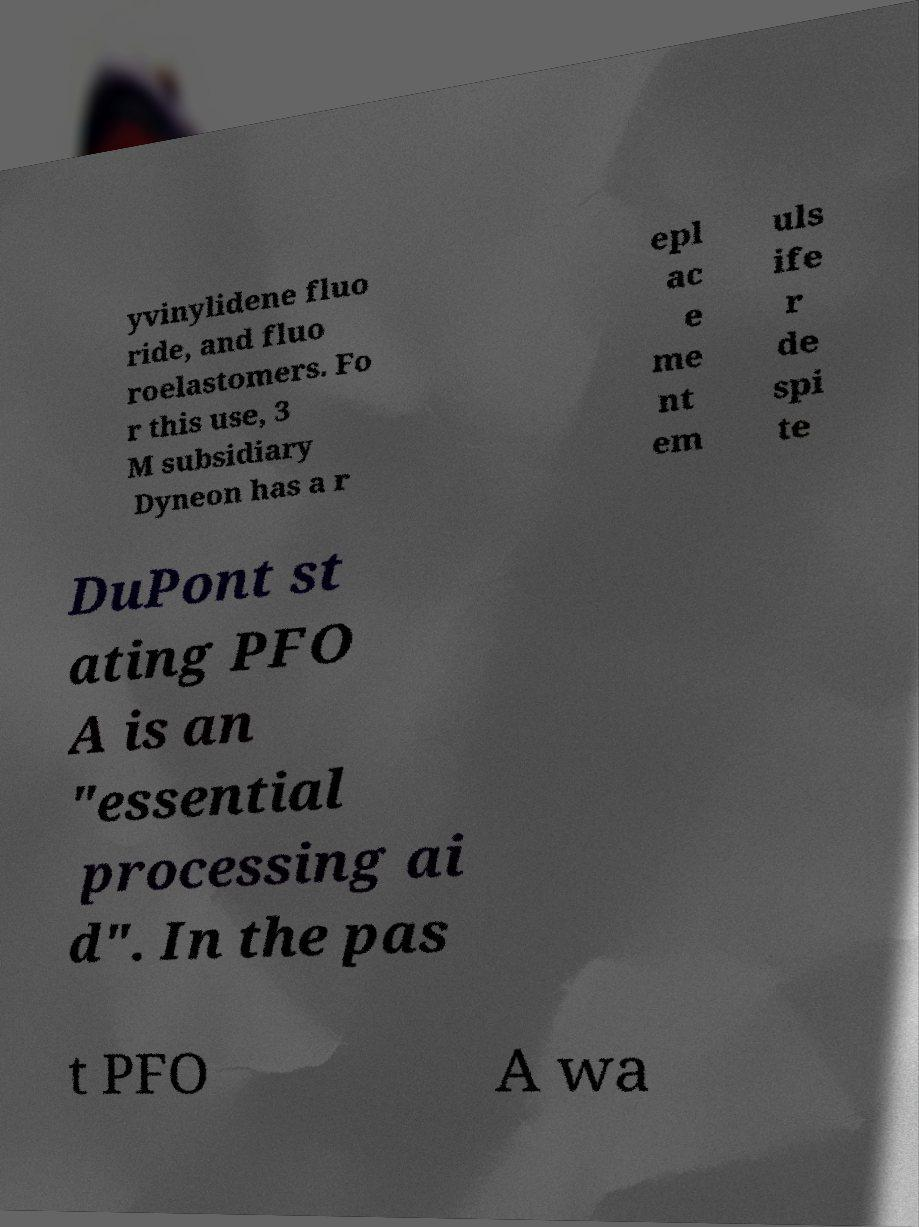Can you accurately transcribe the text from the provided image for me? yvinylidene fluo ride, and fluo roelastomers. Fo r this use, 3 M subsidiary Dyneon has a r epl ac e me nt em uls ife r de spi te DuPont st ating PFO A is an "essential processing ai d". In the pas t PFO A wa 